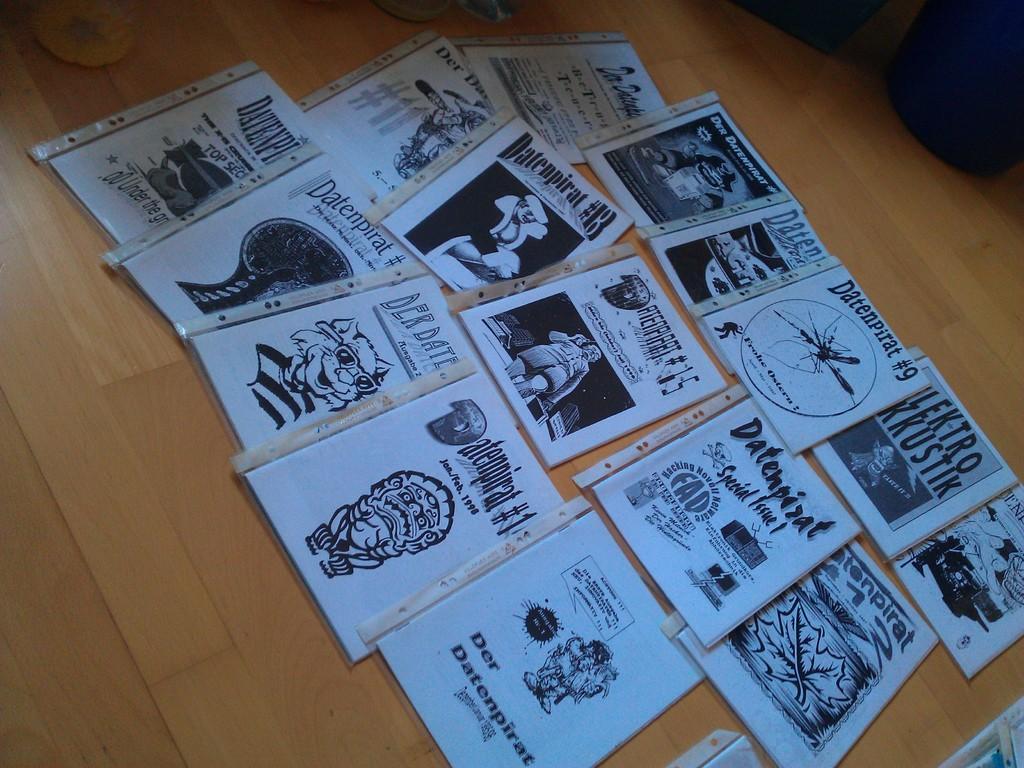Could you give a brief overview of what you see in this image? In this picture, we see the books or the papers containing the sketch of cartoons and the text written are placed on the wooden table or the floor. In the right top, we see an object in black color. 